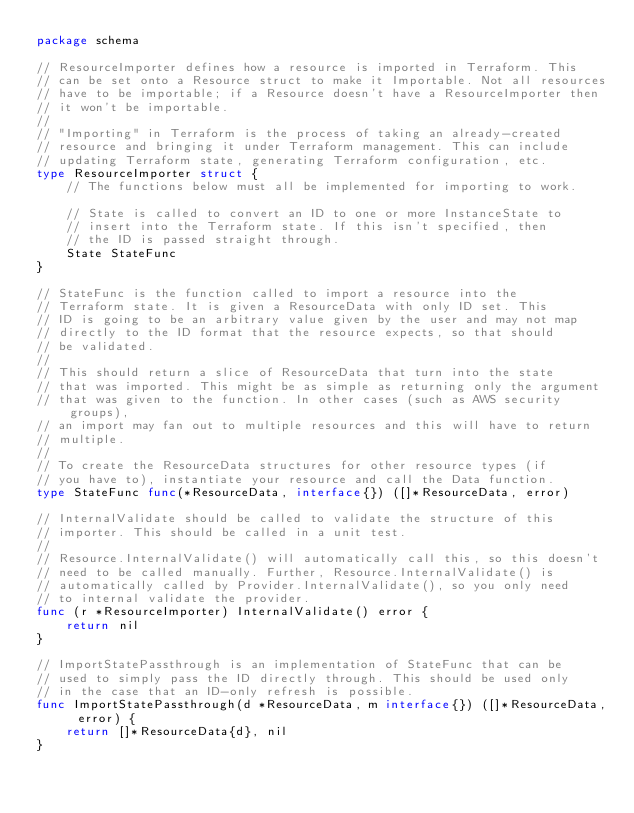<code> <loc_0><loc_0><loc_500><loc_500><_Go_>package schema

// ResourceImporter defines how a resource is imported in Terraform. This
// can be set onto a Resource struct to make it Importable. Not all resources
// have to be importable; if a Resource doesn't have a ResourceImporter then
// it won't be importable.
//
// "Importing" in Terraform is the process of taking an already-created
// resource and bringing it under Terraform management. This can include
// updating Terraform state, generating Terraform configuration, etc.
type ResourceImporter struct {
	// The functions below must all be implemented for importing to work.

	// State is called to convert an ID to one or more InstanceState to
	// insert into the Terraform state. If this isn't specified, then
	// the ID is passed straight through.
	State StateFunc
}

// StateFunc is the function called to import a resource into the
// Terraform state. It is given a ResourceData with only ID set. This
// ID is going to be an arbitrary value given by the user and may not map
// directly to the ID format that the resource expects, so that should
// be validated.
//
// This should return a slice of ResourceData that turn into the state
// that was imported. This might be as simple as returning only the argument
// that was given to the function. In other cases (such as AWS security groups),
// an import may fan out to multiple resources and this will have to return
// multiple.
//
// To create the ResourceData structures for other resource types (if
// you have to), instantiate your resource and call the Data function.
type StateFunc func(*ResourceData, interface{}) ([]*ResourceData, error)

// InternalValidate should be called to validate the structure of this
// importer. This should be called in a unit test.
//
// Resource.InternalValidate() will automatically call this, so this doesn't
// need to be called manually. Further, Resource.InternalValidate() is
// automatically called by Provider.InternalValidate(), so you only need
// to internal validate the provider.
func (r *ResourceImporter) InternalValidate() error {
	return nil
}

// ImportStatePassthrough is an implementation of StateFunc that can be
// used to simply pass the ID directly through. This should be used only
// in the case that an ID-only refresh is possible.
func ImportStatePassthrough(d *ResourceData, m interface{}) ([]*ResourceData, error) {
	return []*ResourceData{d}, nil
}
</code> 